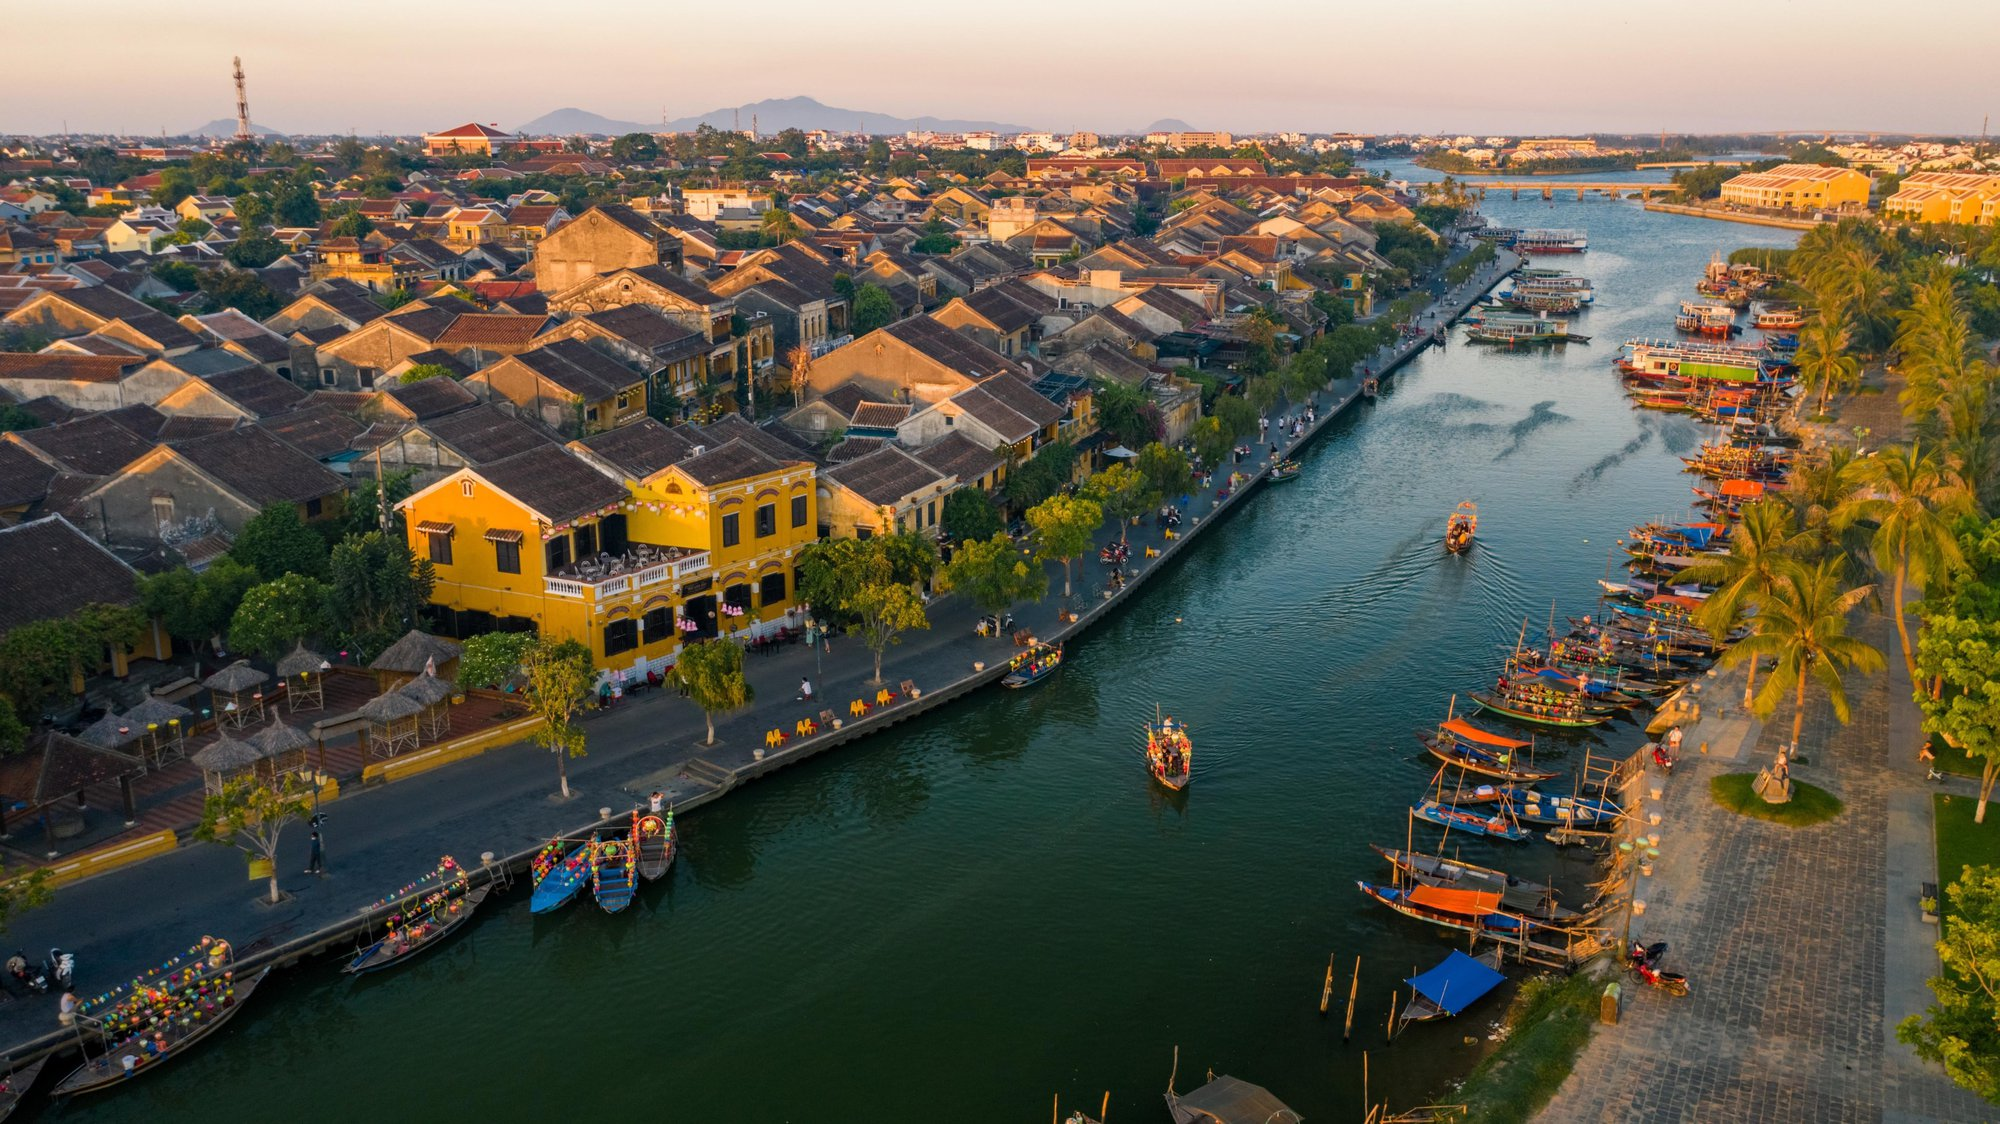What can you infer about the lifestyle of the people living in the buildings along the river? The lifestyle of the people living in the buildings along the river likely revolves around a close relationship with the water. The presence of numerous boats suggests that the river is a central aspect of daily life, used for both transportation and commerce. The well-maintained and historical architecture of the buildings indicates a rich cultural heritage and possibly a strong sense of community. Residents might engage in various water-based activities such as fishing, boating, or participating in local festivals. The vibrant atmosphere created by the lantern-adorned boats suggests that tourism might play a significant role in the local economy, with many residents possibly involved in running businesses catering to visitors. 